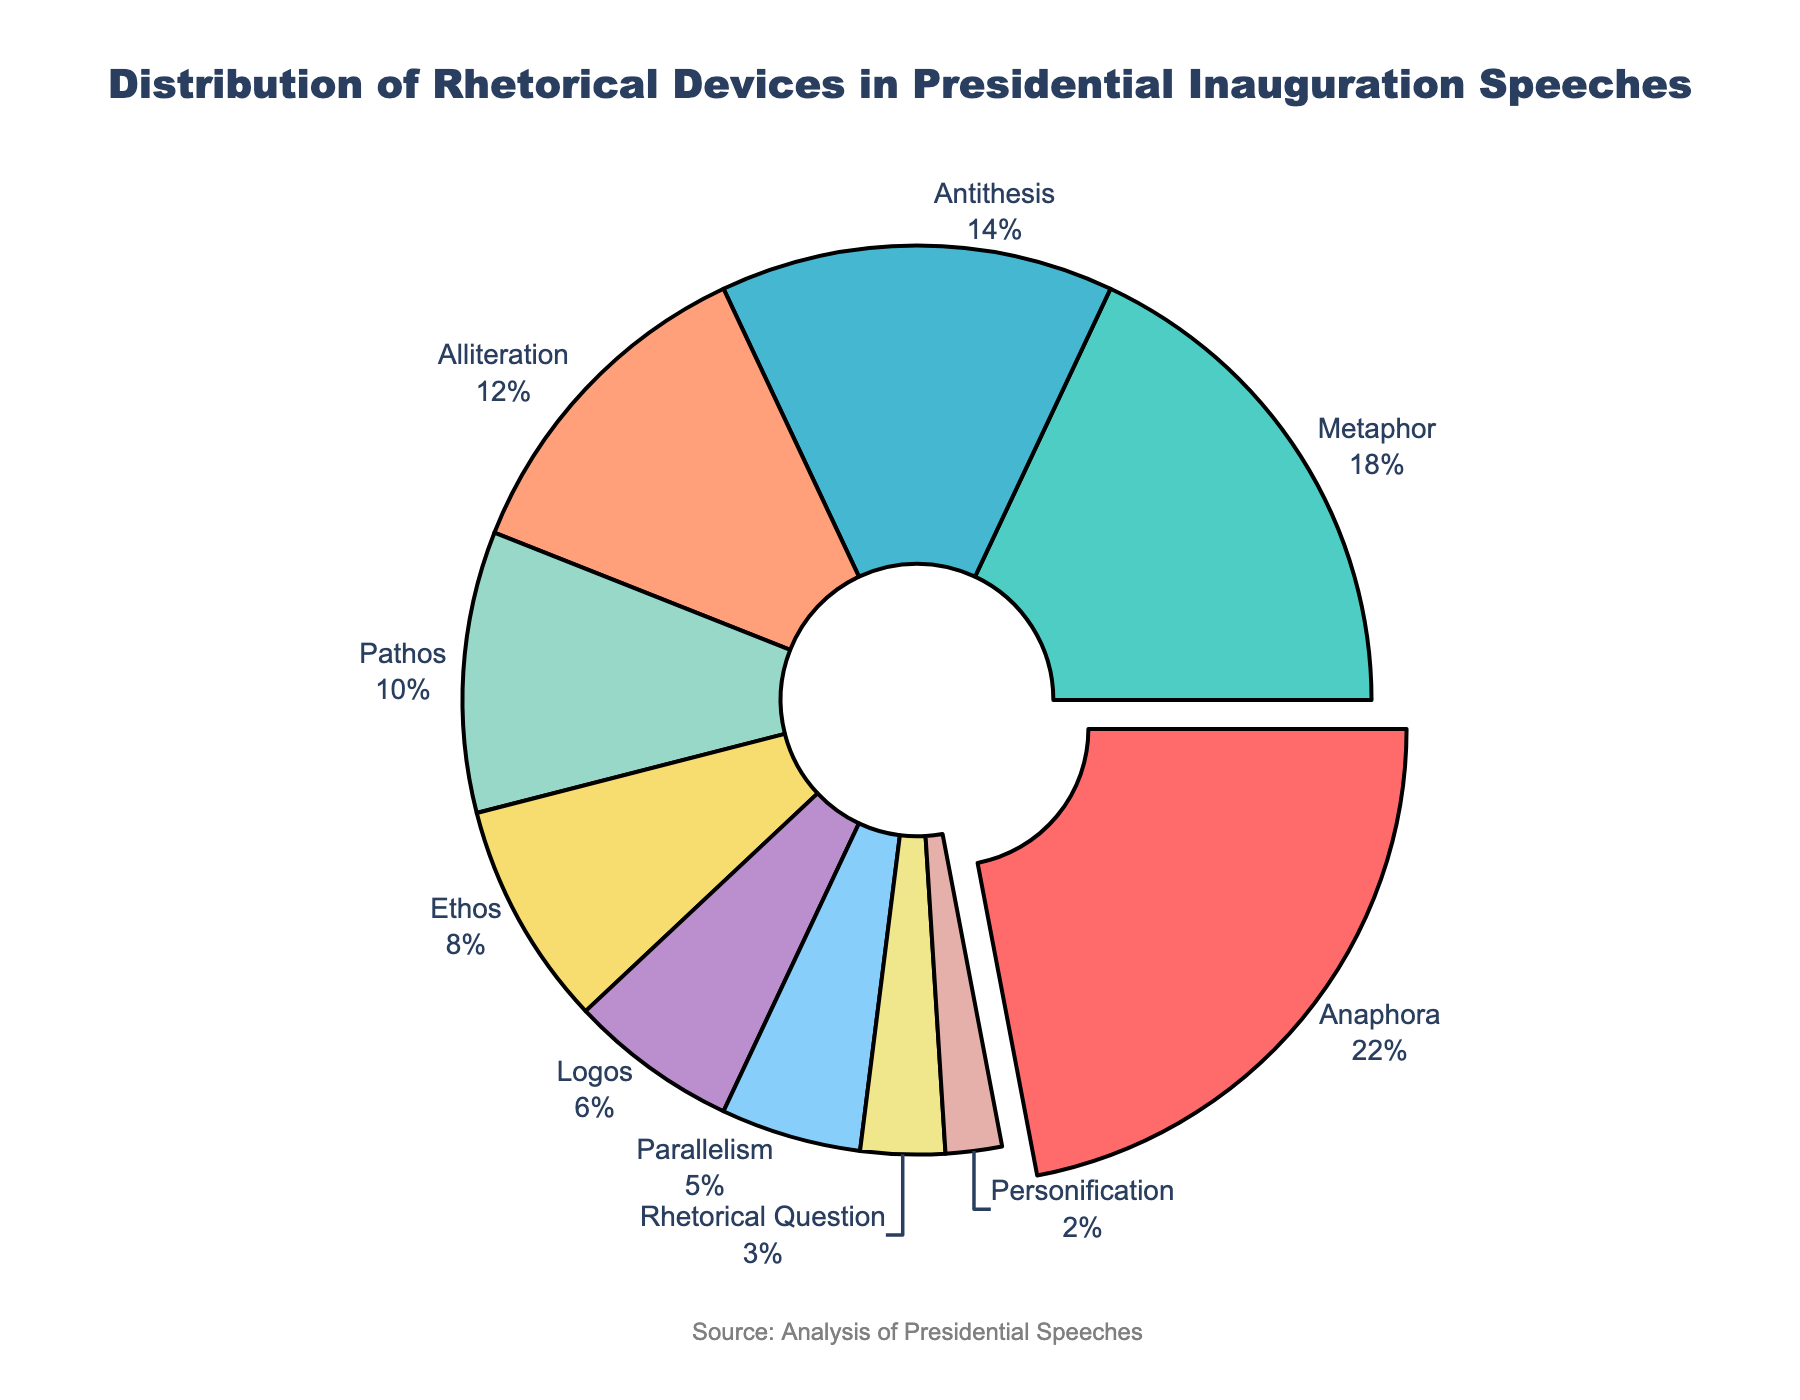What percentage of the pie chart does the largest segment represent? The largest segment represents "Anaphora", with a percentage of 22%. This value is visually represented by the largest segment in the pie chart which has been pulled out for emphasis.
Answer: 22% Which two rhetorical devices combined make up the largest percentage of the pie chart? The top two rhetorical devices are "Anaphora" at 22% and "Metaphor" at 18%. Combined, they account for 22% + 18% = 40% of the total pie chart.
Answer: Anaphora and Metaphor (40%) How does the usage of Alliteration compare to Pathos in terms of their percentage values? Alliteration represents 12% of the pie chart, whereas Pathos represents 10%. Therefore, Alliteration is 2% higher in usage than Pathos.
Answer: Alliteration is 2% more than Pathos What is the total percentage represented by Ethos, Logos, Parallelism, and Rhetorical Question combined? Ethos (8%), Logos (6%), Parallelism (5%), and Rhetorical Question (3%) together sum up to 8% + 6% + 5% + 3% = 22%.
Answer: 22% Which rhetorical device is visually represented by the yellowish segment in the pie chart, and what is its percentage? The yellowish segment represents "Pathos," which has a percentage of 10% in the pie chart. This can be identified by matching the color visual attribute to the chart's legend.
Answer: Pathos (10%) What's the difference in percentage between the rhetorical device with the largest usage and the one with the smallest usage? The rhetorical device with the largest usage is "Anaphora" at 22%, and the smallest is "Personification" at 2%. The difference between them is 22% - 2% = 20%.
Answer: 20% If you combined Antithesis and Alliteration, how much more would their combined percentage be compared to Metaphor alone? Antithesis (14%) combined with Alliteration (12%) gives a total of 14% + 12% = 26%. Metaphor alone is 18%. The difference is 26% - 18% = 8%.
Answer: 8% more What percentage of the pie chart is attributed to non-logical rhetorical devices (excluding Logos)? Excluding "Logos" (6%), the remaining devices are: Anaphora (22%), Metaphor (18%), Antithesis (14%), Alliteration (12%), Pathos (10%), Ethos (8%), Parallelism (5%), Rhetorical Question (3%), and Personification (2%). Summed up, this gives 22% + 18% + 14% + 12% + 10% + 8% + 5% + 3% + 2% = 94%.
Answer: 94% Which rhetorical device does the smallest segment represent and what color is it? The smallest segment represents "Personification" and the visual representation is by the light pink segment.
Answer: Personification (light pink) 